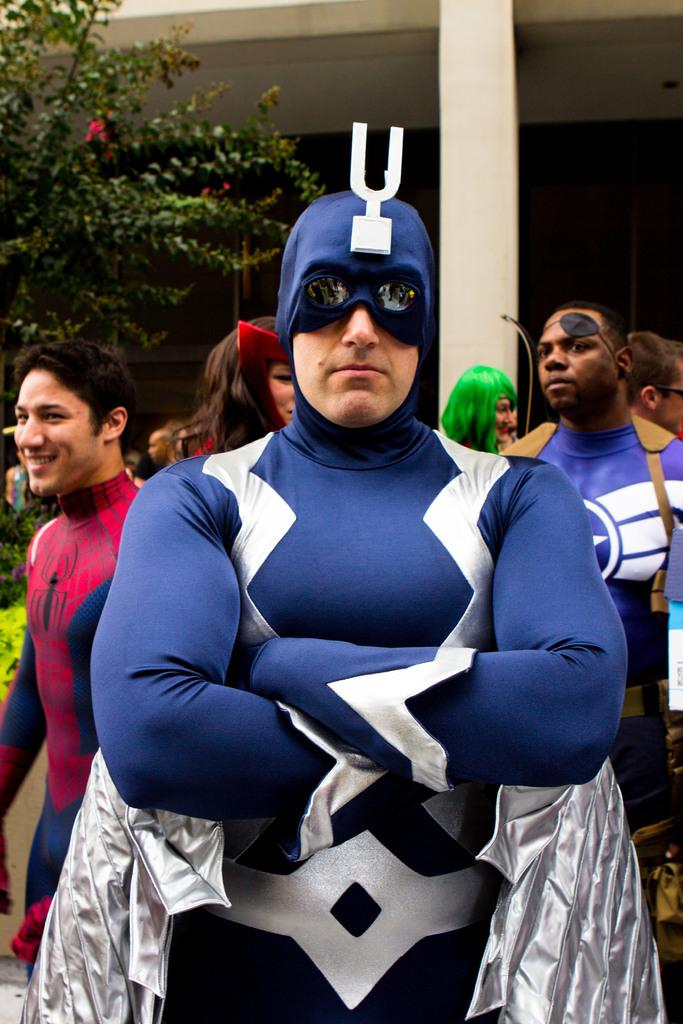How many people are in the image? There is a group of people in the image, but the exact number is not specified. What can be seen in the background of the image? There is a pillar, trees, and a building in the background of the image. What type of honey is being served at the party in the image? There is no party or honey present in the image. Can you describe the stranger in the image? There is no stranger present in the image; it features a group of people. 